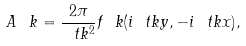<formula> <loc_0><loc_0><loc_500><loc_500>\ A _ { \ } k = \frac { 2 \pi } { \ t k ^ { 2 } } f _ { \ } k ( i \ t k y , - i \ t k x ) ,</formula> 